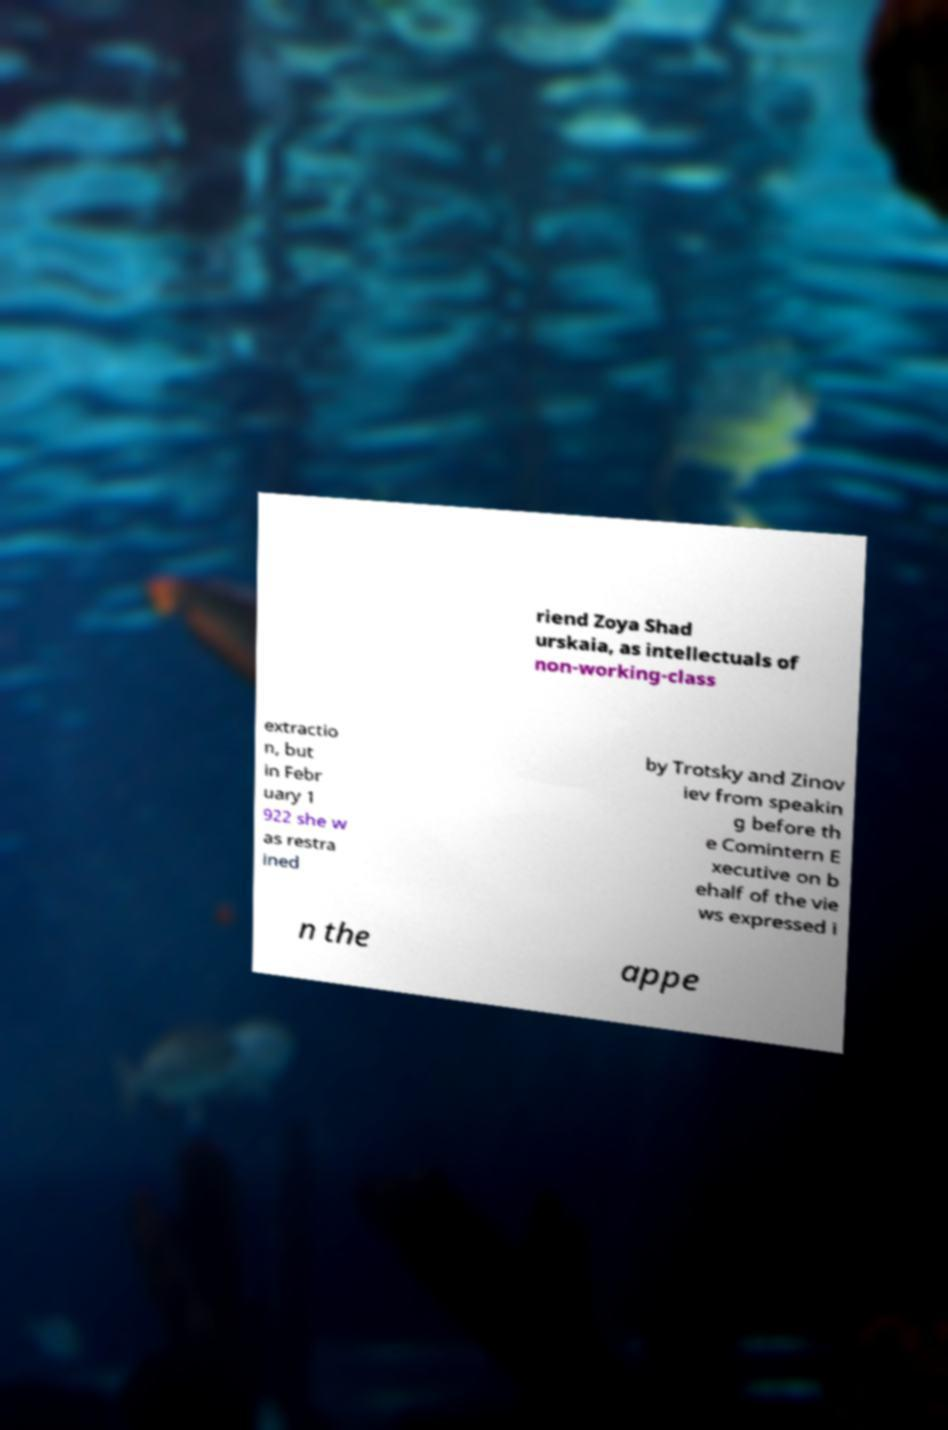Can you read and provide the text displayed in the image?This photo seems to have some interesting text. Can you extract and type it out for me? riend Zoya Shad urskaia, as intellectuals of non-working-class extractio n, but in Febr uary 1 922 she w as restra ined by Trotsky and Zinov iev from speakin g before th e Comintern E xecutive on b ehalf of the vie ws expressed i n the appe 